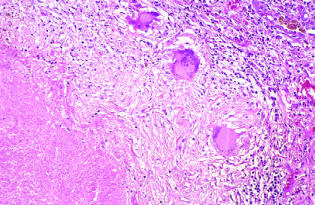what takes the form of a three-dimensional sphere with the offending organism in the central area?
Answer the question using a single word or phrase. The granulomatous response 